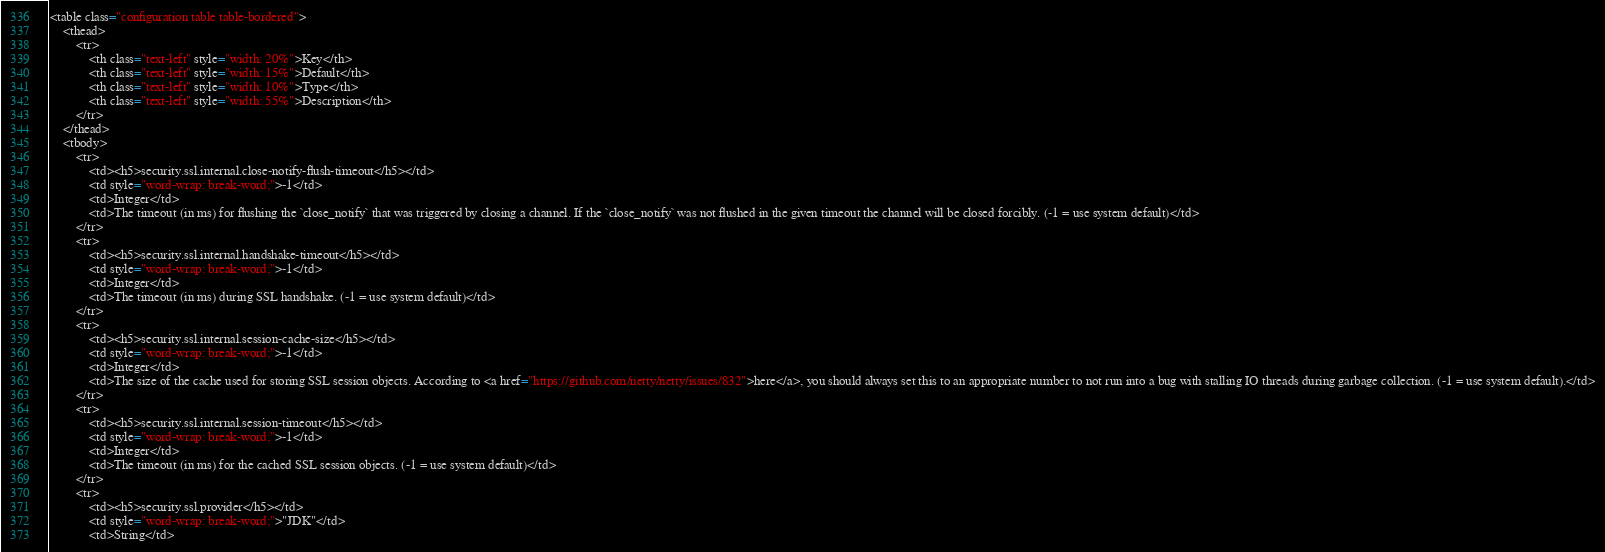Convert code to text. <code><loc_0><loc_0><loc_500><loc_500><_HTML_><table class="configuration table table-bordered">
    <thead>
        <tr>
            <th class="text-left" style="width: 20%">Key</th>
            <th class="text-left" style="width: 15%">Default</th>
            <th class="text-left" style="width: 10%">Type</th>
            <th class="text-left" style="width: 55%">Description</th>
        </tr>
    </thead>
    <tbody>
        <tr>
            <td><h5>security.ssl.internal.close-notify-flush-timeout</h5></td>
            <td style="word-wrap: break-word;">-1</td>
            <td>Integer</td>
            <td>The timeout (in ms) for flushing the `close_notify` that was triggered by closing a channel. If the `close_notify` was not flushed in the given timeout the channel will be closed forcibly. (-1 = use system default)</td>
        </tr>
        <tr>
            <td><h5>security.ssl.internal.handshake-timeout</h5></td>
            <td style="word-wrap: break-word;">-1</td>
            <td>Integer</td>
            <td>The timeout (in ms) during SSL handshake. (-1 = use system default)</td>
        </tr>
        <tr>
            <td><h5>security.ssl.internal.session-cache-size</h5></td>
            <td style="word-wrap: break-word;">-1</td>
            <td>Integer</td>
            <td>The size of the cache used for storing SSL session objects. According to <a href="https://github.com/netty/netty/issues/832">here</a>, you should always set this to an appropriate number to not run into a bug with stalling IO threads during garbage collection. (-1 = use system default).</td>
        </tr>
        <tr>
            <td><h5>security.ssl.internal.session-timeout</h5></td>
            <td style="word-wrap: break-word;">-1</td>
            <td>Integer</td>
            <td>The timeout (in ms) for the cached SSL session objects. (-1 = use system default)</td>
        </tr>
        <tr>
            <td><h5>security.ssl.provider</h5></td>
            <td style="word-wrap: break-word;">"JDK"</td>
            <td>String</td></code> 